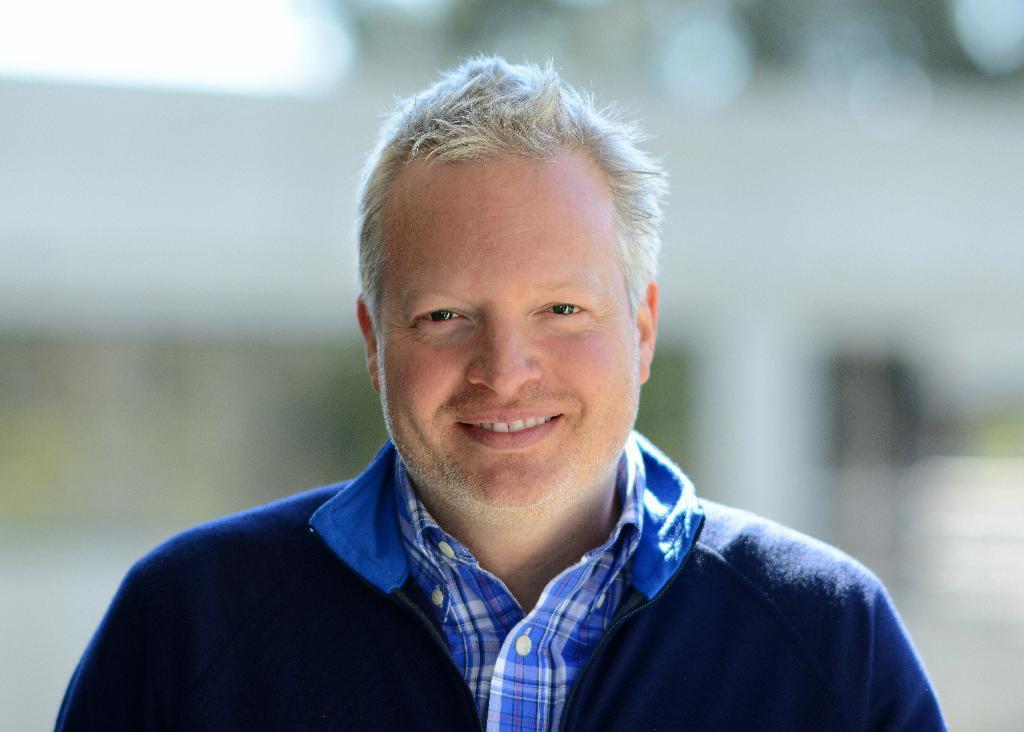In one or two sentences, can you explain what this image depicts? in this image we can see a person wearing a blue jacket and a shirt. 